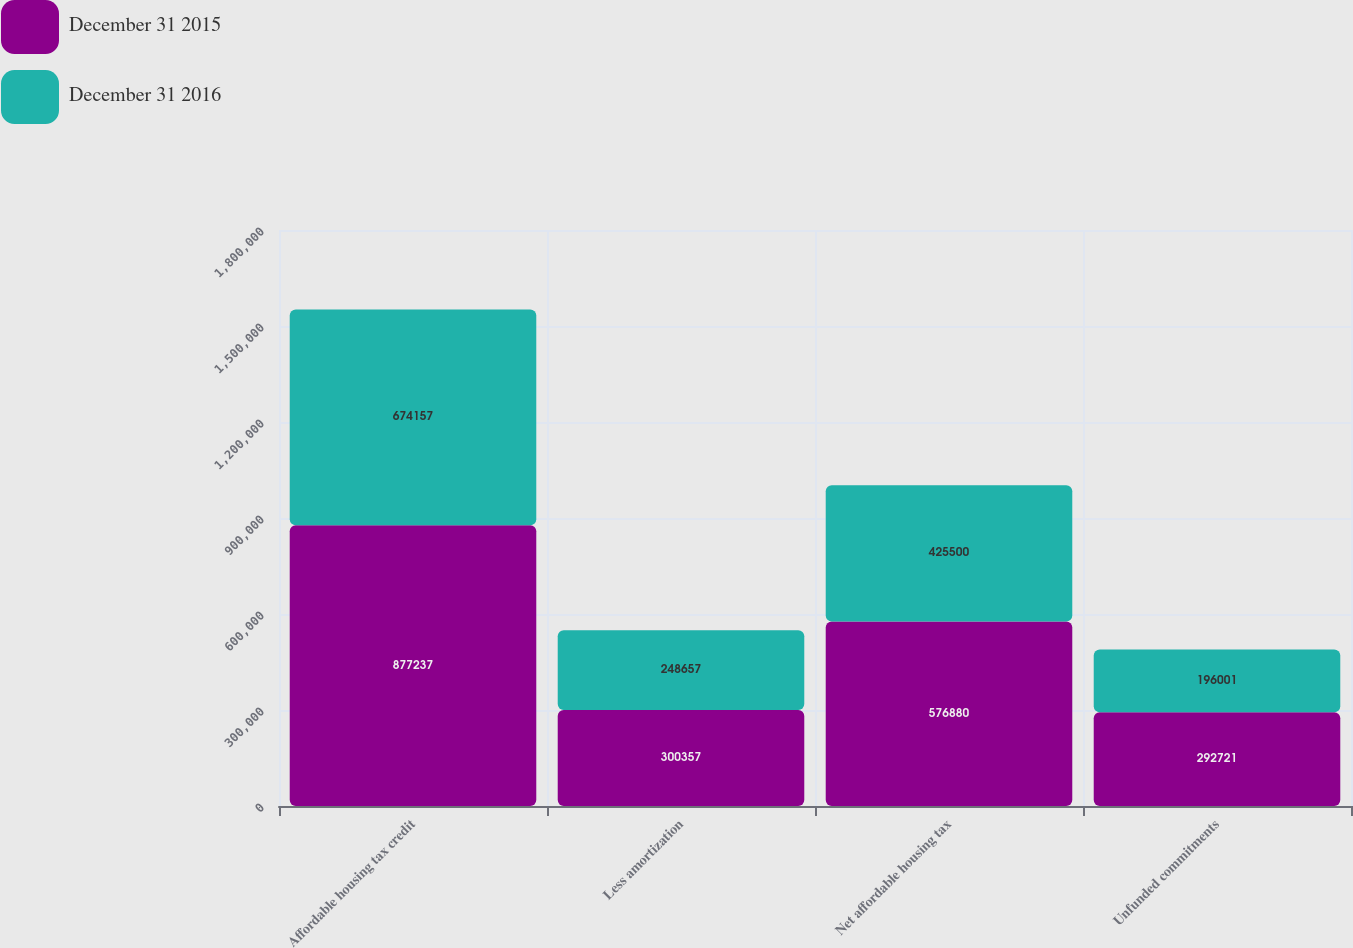<chart> <loc_0><loc_0><loc_500><loc_500><stacked_bar_chart><ecel><fcel>Affordable housing tax credit<fcel>Less amortization<fcel>Net affordable housing tax<fcel>Unfunded commitments<nl><fcel>December 31 2015<fcel>877237<fcel>300357<fcel>576880<fcel>292721<nl><fcel>December 31 2016<fcel>674157<fcel>248657<fcel>425500<fcel>196001<nl></chart> 